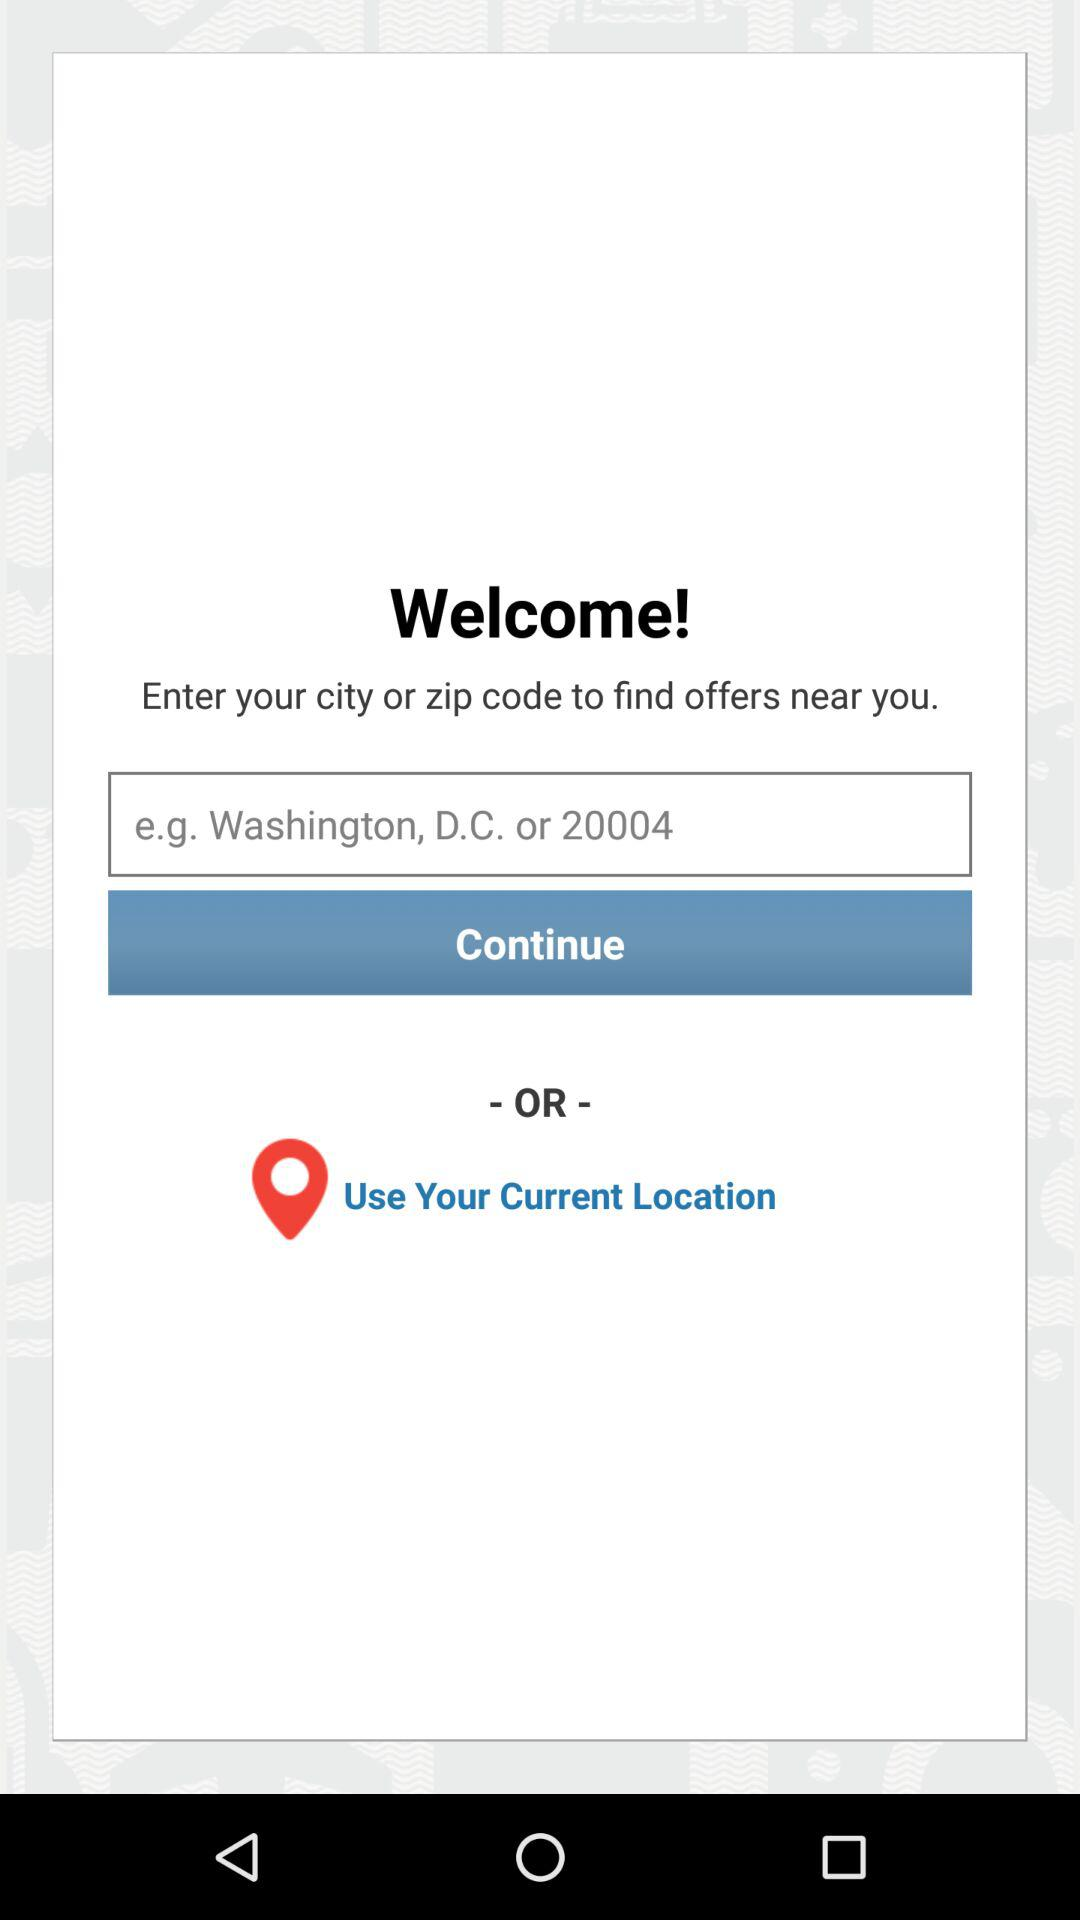How many input options are there for finding offers?
Answer the question using a single word or phrase. 2 